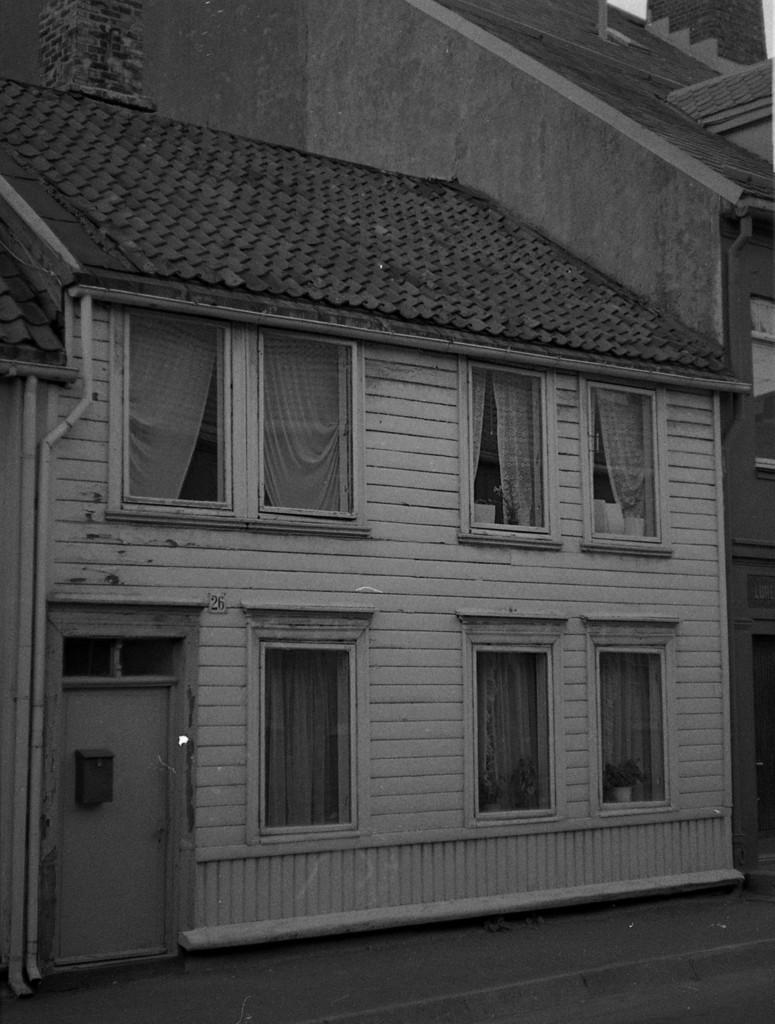Could you give a brief overview of what you see in this image? In this image we can see a house with a roof, windows, curtains and a door. 